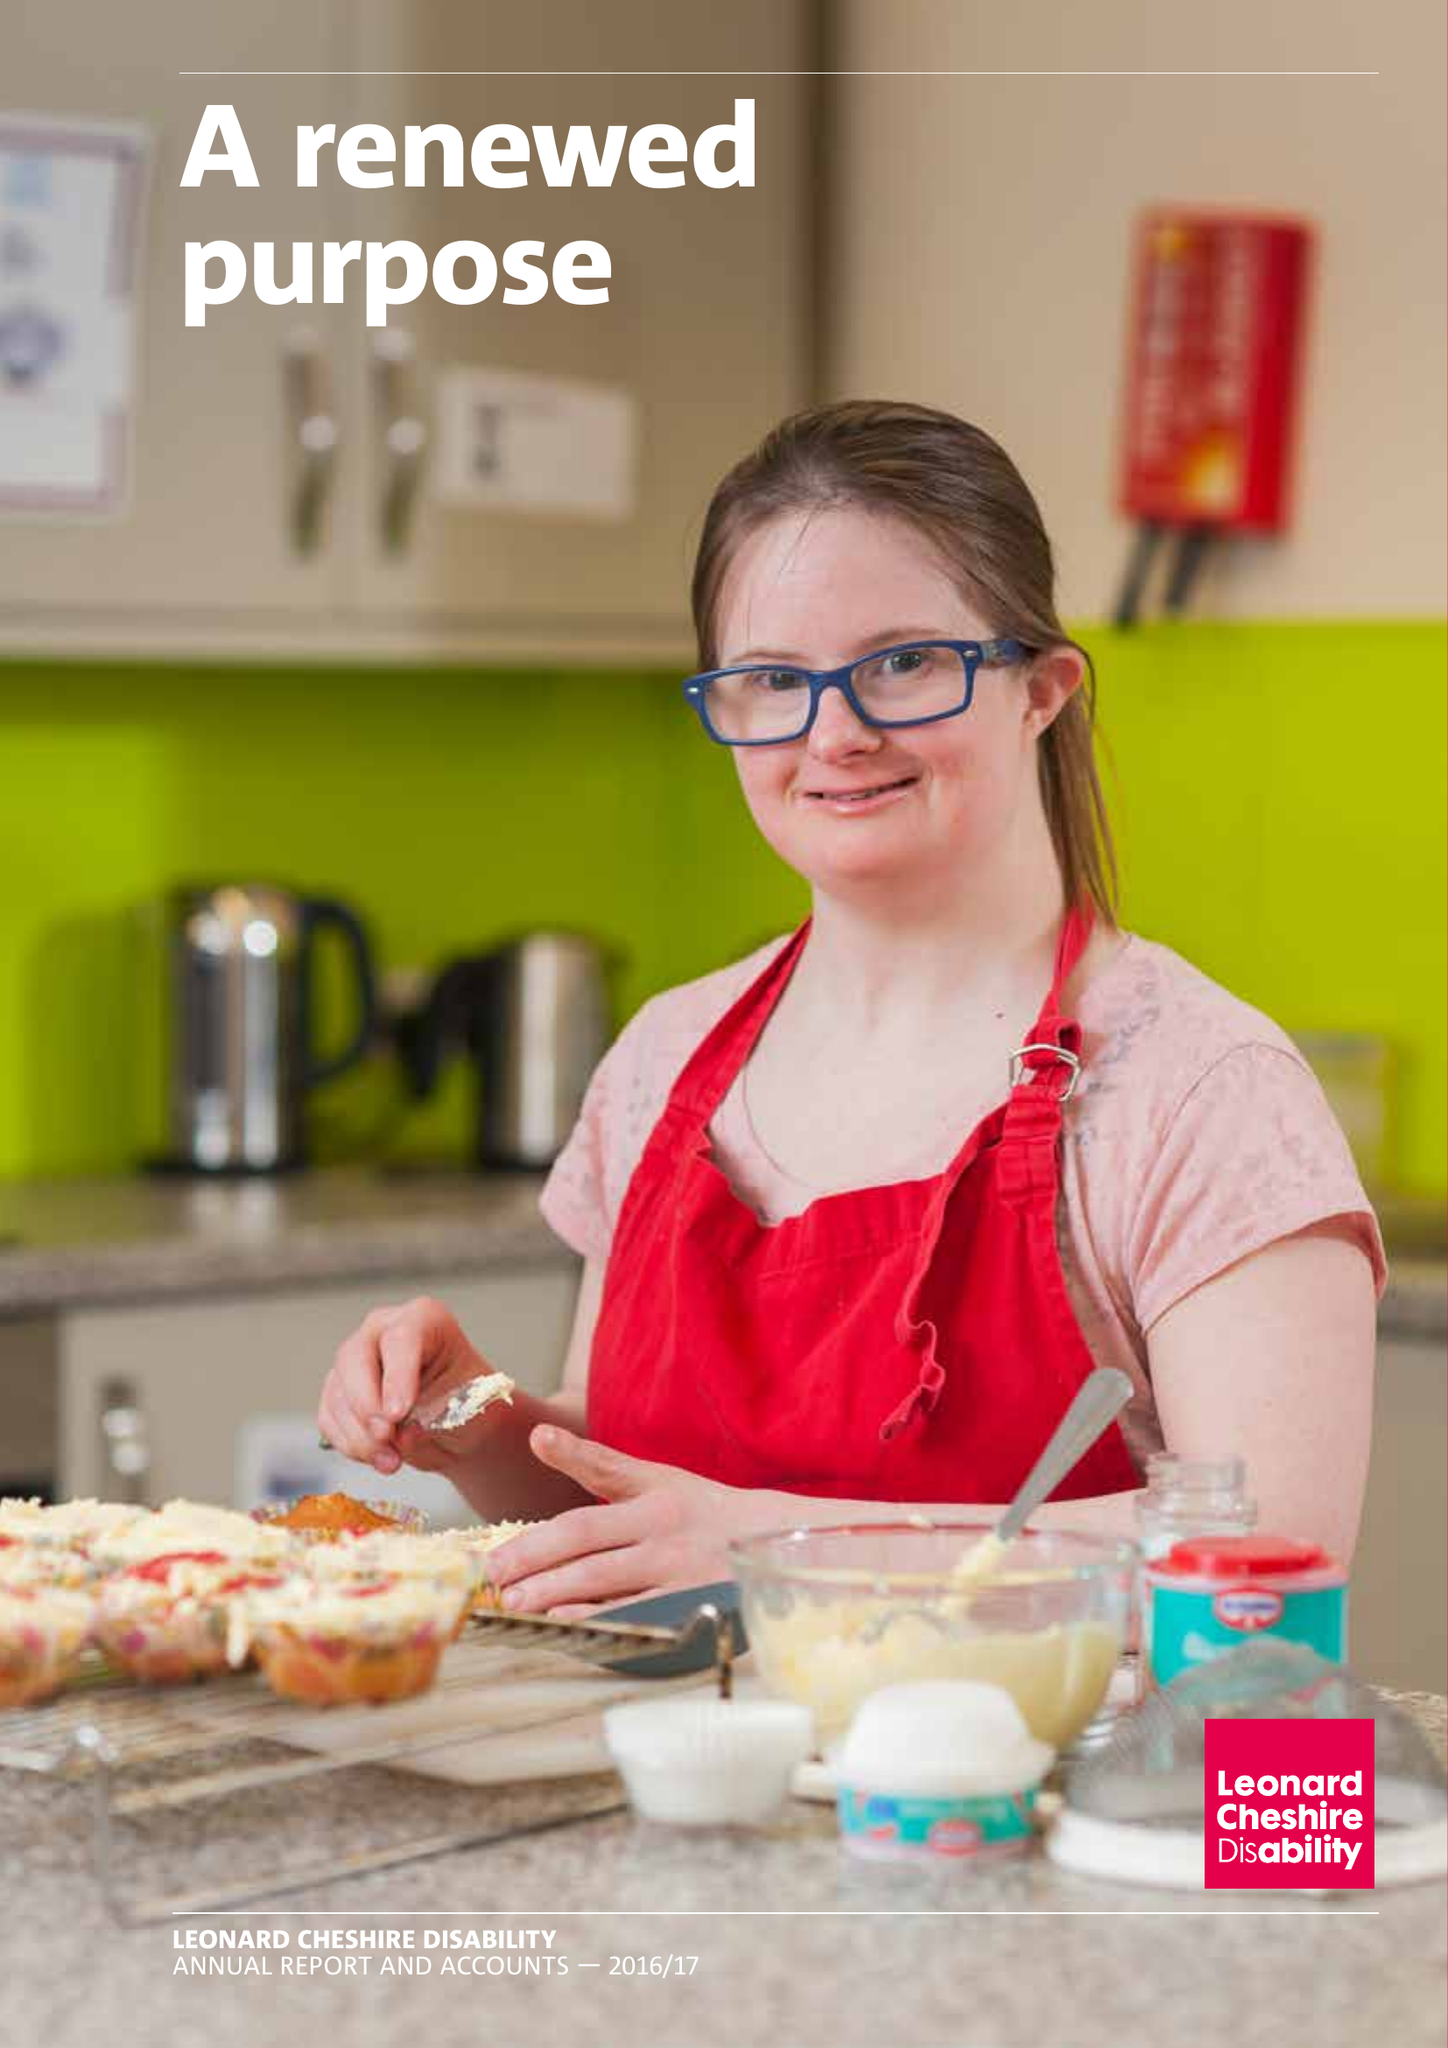What is the value for the income_annually_in_british_pounds?
Answer the question using a single word or phrase. 161339000.00 